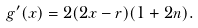Convert formula to latex. <formula><loc_0><loc_0><loc_500><loc_500>g ^ { \prime } ( x ) = 2 ( 2 x - r ) ( 1 + 2 n ) .</formula> 